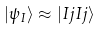<formula> <loc_0><loc_0><loc_500><loc_500>| \psi _ { I } \rangle \approx | I j I j \rangle</formula> 